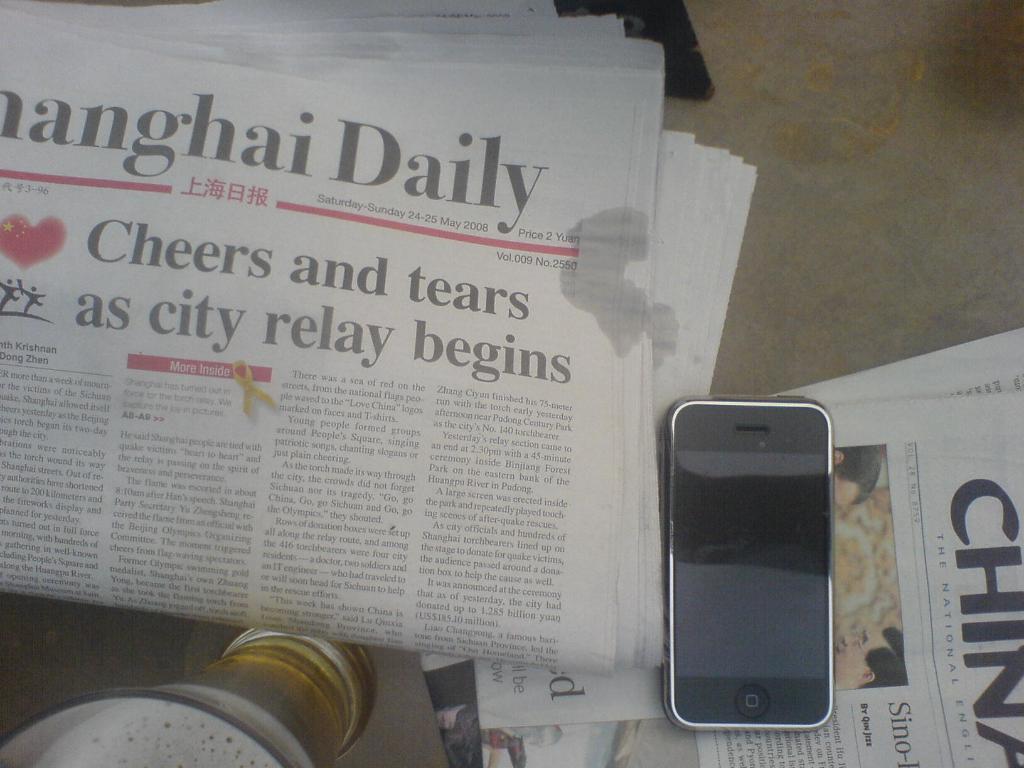In one or two sentences, can you explain what this image depicts? This image is taken indoors. In this image there is a table with a few newspapers, a mobile phone and a glass with wine on it. 